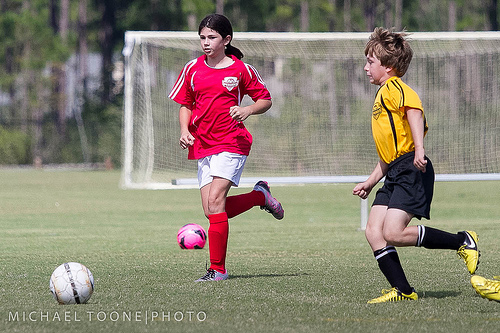<image>
Is there a ball under the net? No. The ball is not positioned under the net. The vertical relationship between these objects is different. Is there a boy behind the girl? No. The boy is not behind the girl. From this viewpoint, the boy appears to be positioned elsewhere in the scene. 